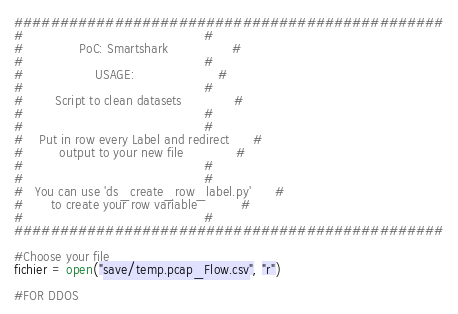<code> <loc_0><loc_0><loc_500><loc_500><_Python_>###############################################
#                                             #
#              PoC: Smartshark                #
#                                             #
#                  USAGE:                     #
#                                             #
#        Script to clean datasets             #
#                                             #
#                                             #
#    Put in row every Label and redirect      #
#         output to your new file             #
#                                             #
#                                             #
#   You can use 'ds_create_row_label.py'      #
#       to create your row variable           #
#                                             #
###############################################

#Choose your file
fichier = open("save/temp.pcap_Flow.csv", "r")

#FOR DDOS
</code> 